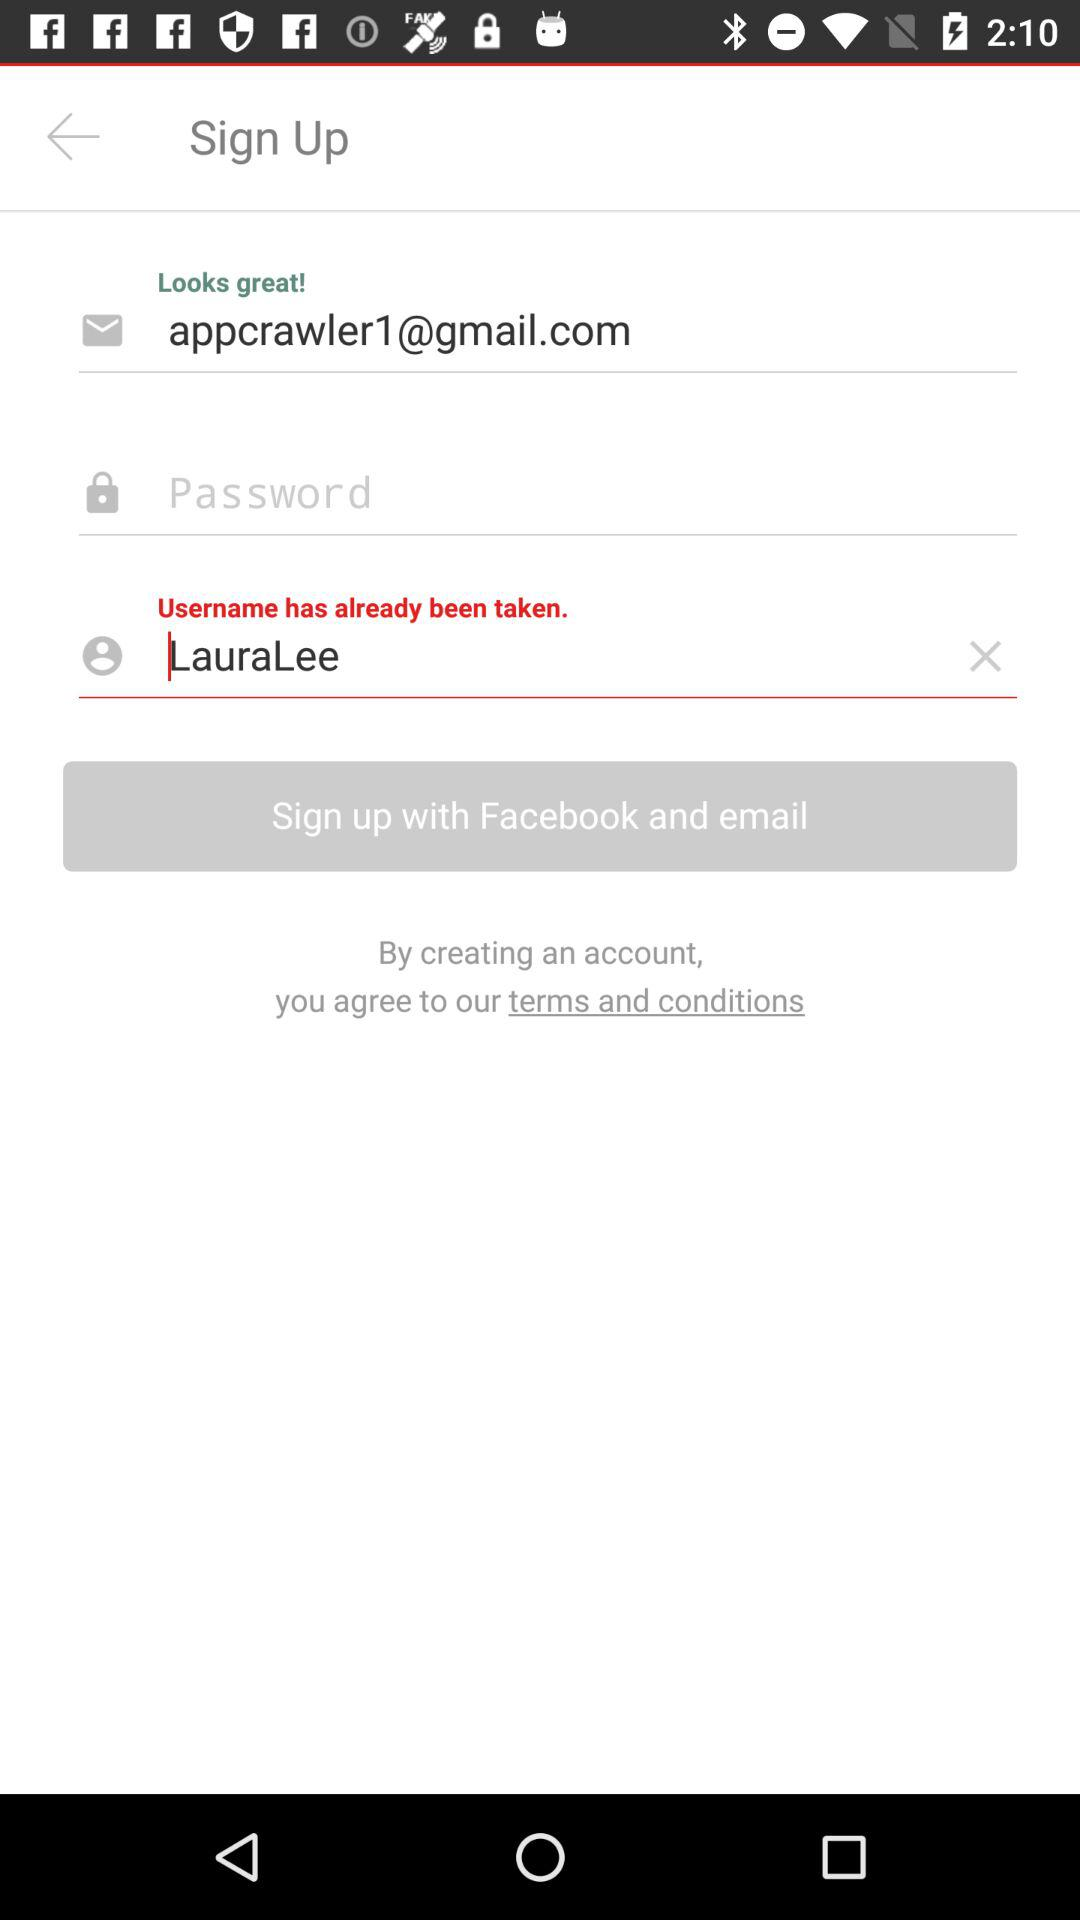What is the email address? The email address is appcrawler1@gmail.com. 